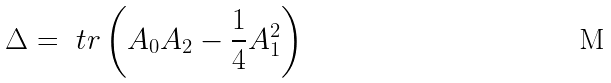<formula> <loc_0><loc_0><loc_500><loc_500>\Delta = \ t r \left ( A _ { 0 } A _ { 2 } - \frac { 1 } { 4 } A _ { 1 } ^ { 2 } \right )</formula> 